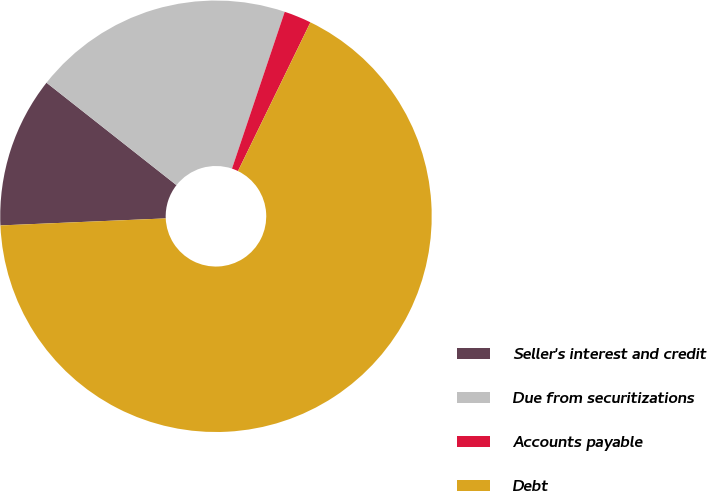<chart> <loc_0><loc_0><loc_500><loc_500><pie_chart><fcel>Seller's interest and credit<fcel>Due from securitizations<fcel>Accounts payable<fcel>Debt<nl><fcel>11.3%<fcel>19.54%<fcel>2.05%<fcel>67.11%<nl></chart> 